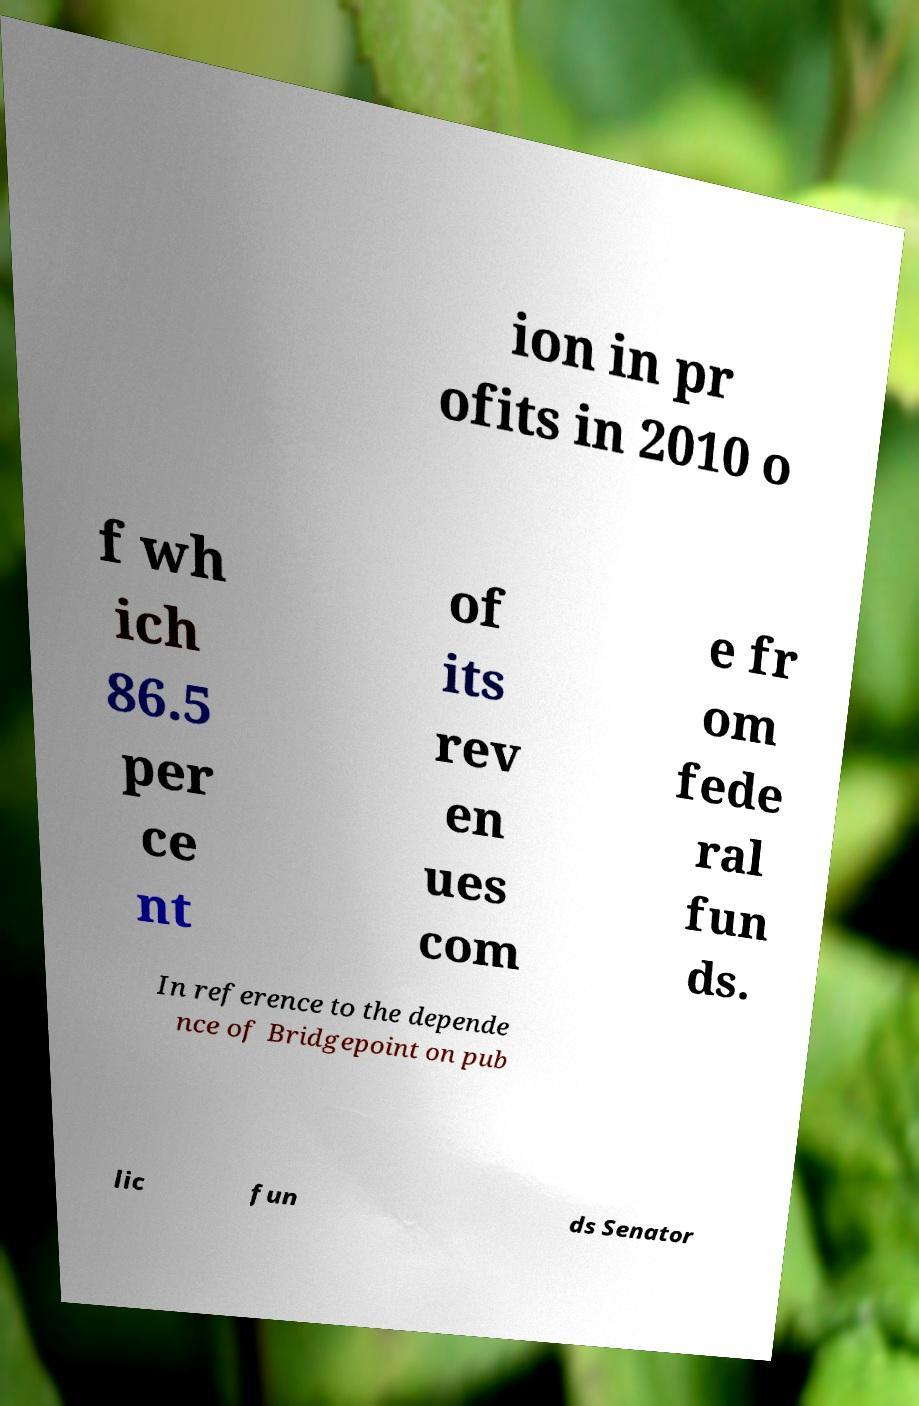Please identify and transcribe the text found in this image. ion in pr ofits in 2010 o f wh ich 86.5 per ce nt of its rev en ues com e fr om fede ral fun ds. In reference to the depende nce of Bridgepoint on pub lic fun ds Senator 